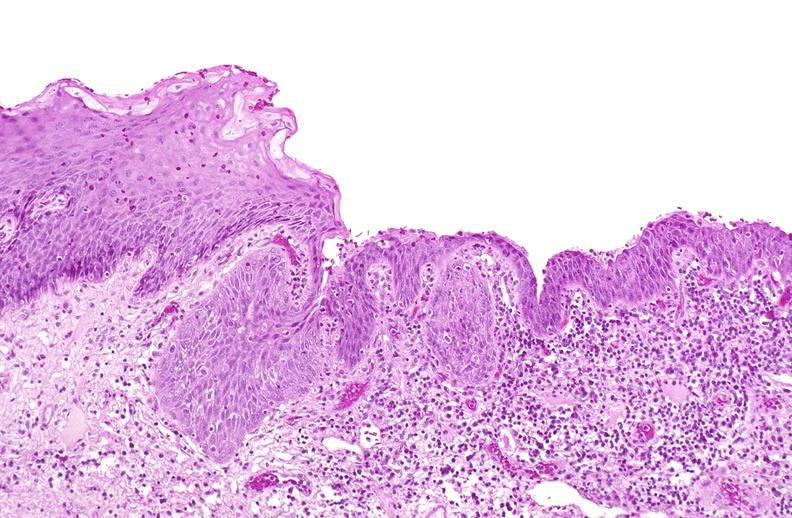s urinary present?
Answer the question using a single word or phrase. Yes 